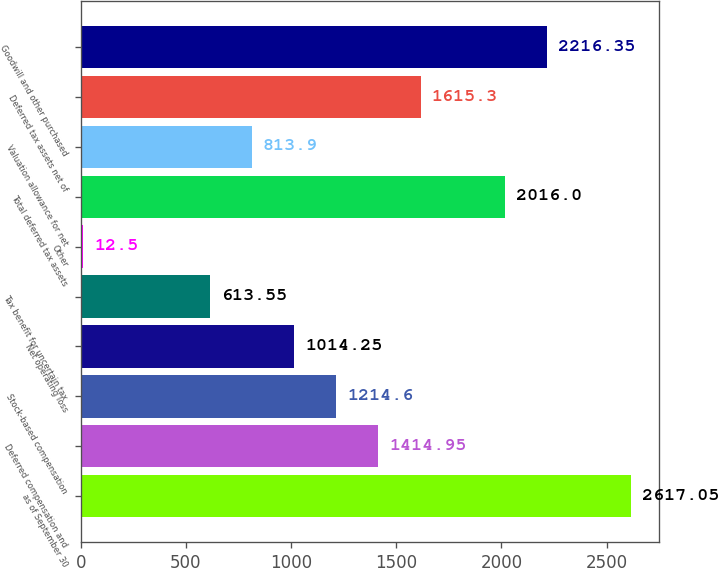Convert chart to OTSL. <chart><loc_0><loc_0><loc_500><loc_500><bar_chart><fcel>as of September 30<fcel>Deferred compensation and<fcel>Stock-based compensation<fcel>Net operating loss<fcel>Tax benefit for uncertain tax<fcel>Other<fcel>Total deferred tax assets<fcel>Valuation allowance for net<fcel>Deferred tax assets net of<fcel>Goodwill and other purchased<nl><fcel>2617.05<fcel>1414.95<fcel>1214.6<fcel>1014.25<fcel>613.55<fcel>12.5<fcel>2016<fcel>813.9<fcel>1615.3<fcel>2216.35<nl></chart> 